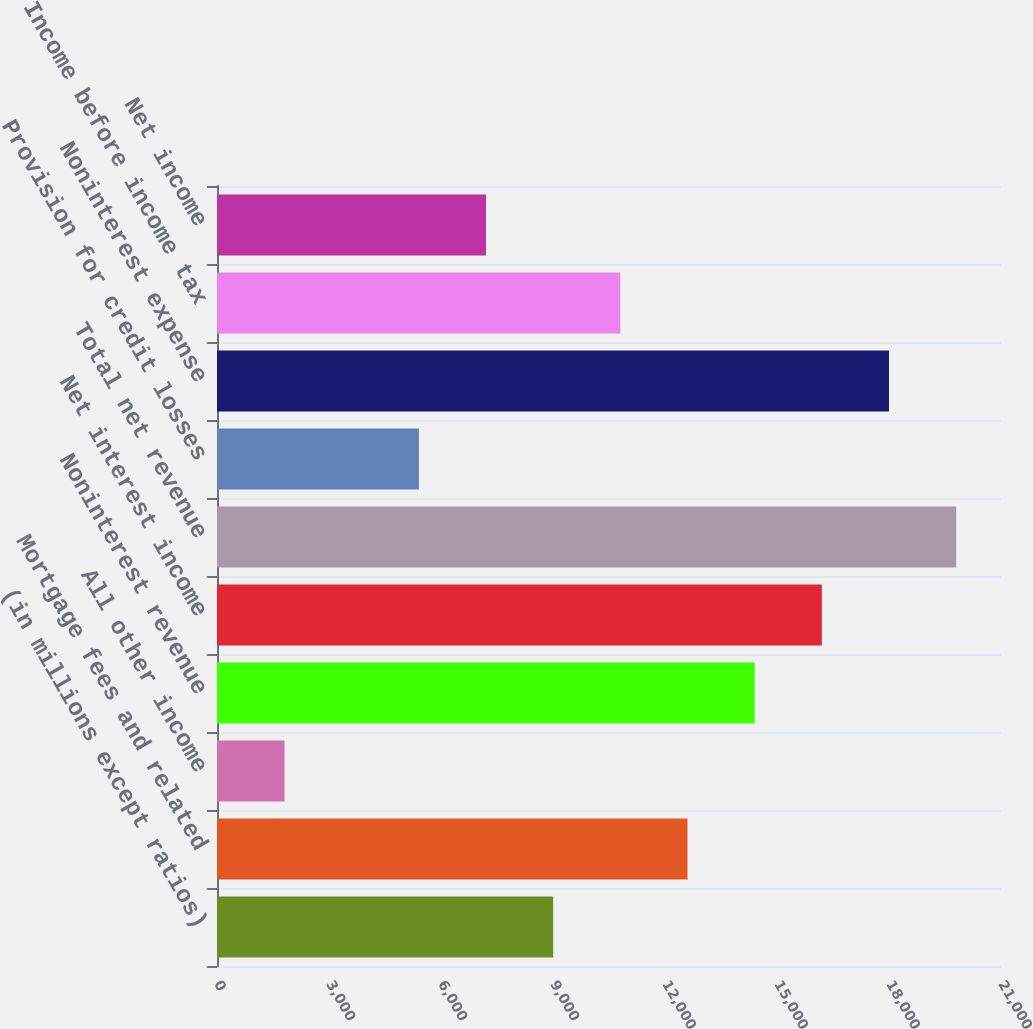Convert chart. <chart><loc_0><loc_0><loc_500><loc_500><bar_chart><fcel>(in millions except ratios)<fcel>Mortgage fees and related<fcel>All other income<fcel>Noninterest revenue<fcel>Net interest income<fcel>Total net revenue<fcel>Provision for credit losses<fcel>Noninterest expense<fcel>Income before income tax<fcel>Net income<nl><fcel>9004.5<fcel>12602.7<fcel>1808.1<fcel>14401.8<fcel>16200.9<fcel>19799.1<fcel>5406.3<fcel>18000<fcel>10803.6<fcel>7205.4<nl></chart> 